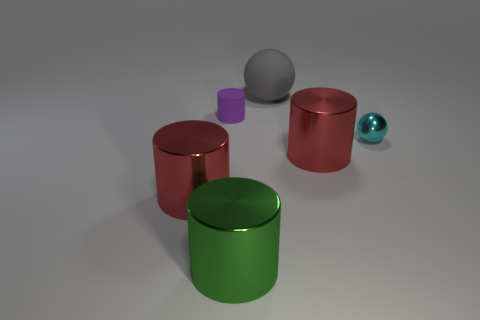Are there any small metallic spheres left of the large red object on the right side of the tiny purple object?
Offer a very short reply. No. There is a tiny matte thing behind the large object that is left of the green thing; how many tiny cyan metallic things are to the left of it?
Your answer should be compact. 0. Are there fewer shiny spheres than big brown cylinders?
Offer a terse response. No. Is the shape of the matte object that is to the left of the big rubber sphere the same as the red metal thing to the left of the big sphere?
Your answer should be very brief. Yes. What is the color of the small ball?
Provide a short and direct response. Cyan. How many rubber objects are either green cylinders or large purple cylinders?
Your answer should be very brief. 0. There is another tiny thing that is the same shape as the green thing; what color is it?
Your response must be concise. Purple. Are there any large gray matte cylinders?
Offer a very short reply. No. Is the material of the big thing left of the tiny purple cylinder the same as the small thing that is to the left of the green shiny thing?
Your response must be concise. No. What number of things are either red things on the left side of the gray thing or objects to the left of the cyan shiny ball?
Keep it short and to the point. 5. 